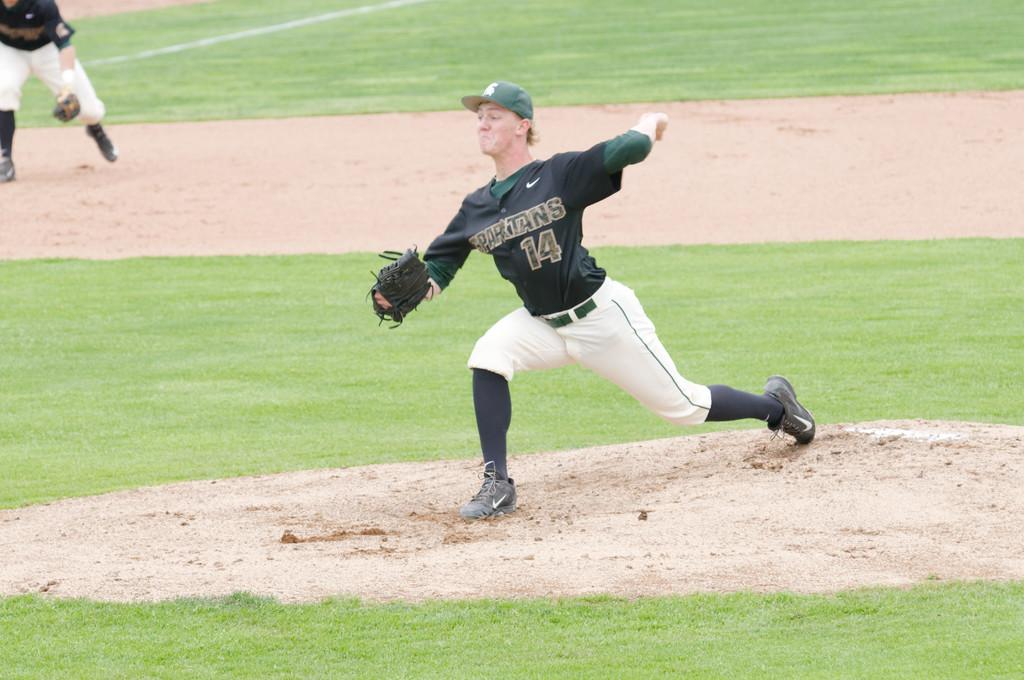How many people are playing in the image? There are two players in the image. Where are the players playing? The players are playing on a playground. What type of fuel is being used by the players in the image? There is no mention of fuel in the image, as it features two players on a playground. 